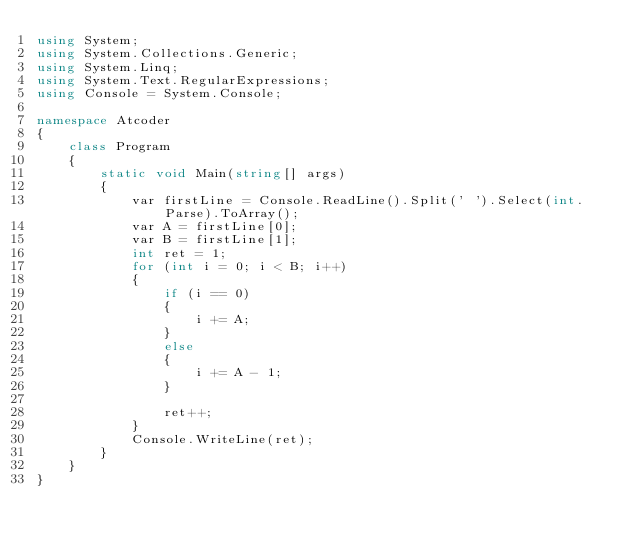Convert code to text. <code><loc_0><loc_0><loc_500><loc_500><_C#_>using System;
using System.Collections.Generic;
using System.Linq;
using System.Text.RegularExpressions;
using Console = System.Console;

namespace Atcoder
{
    class Program
    {
        static void Main(string[] args)
        {
            var firstLine = Console.ReadLine().Split(' ').Select(int.Parse).ToArray();
            var A = firstLine[0];
            var B = firstLine[1];
            int ret = 1;
            for (int i = 0; i < B; i++)
            {
                if (i == 0)
                {
                    i += A;
                }
                else
                {
                    i += A - 1;
                }

                ret++;
            }
            Console.WriteLine(ret);
        }
    }
}</code> 